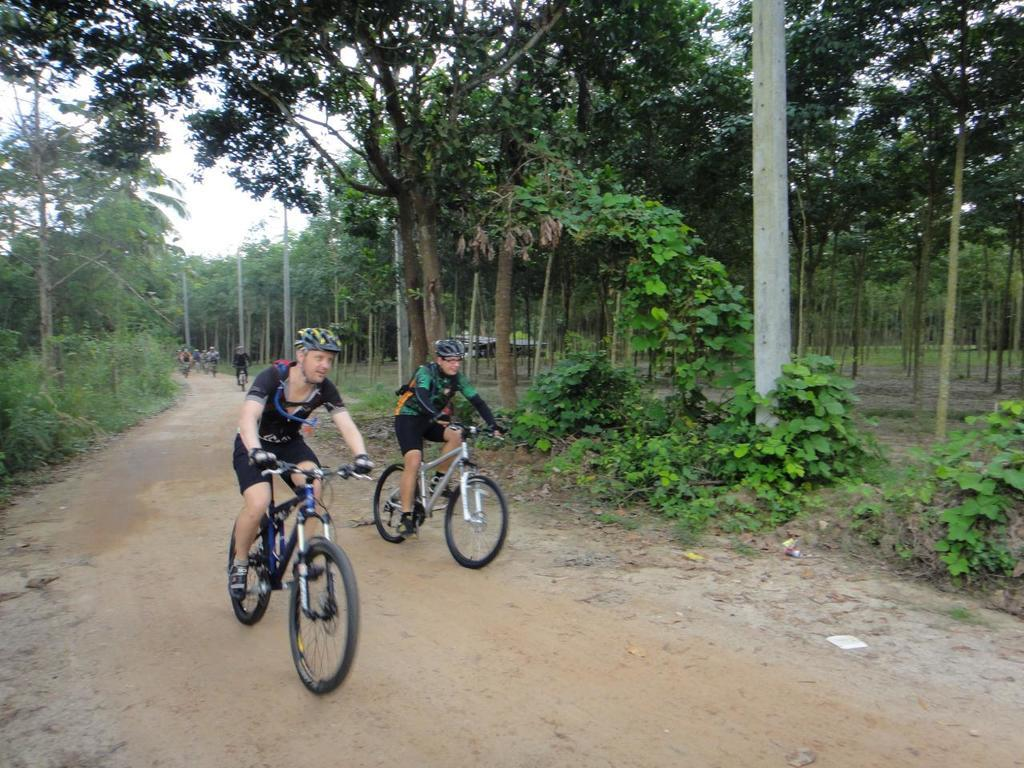What are the people in the image doing? The people in the image are cycling on the road. What else can be seen in the image besides the people cycling? There are plants visible in the image. What is in the background of the image? There are trees and the sky visible in the background of the image. Can you see an arch in the image? There is no arch present in the image. Are there any balloons visible in the image? There are no balloons present in the image. 